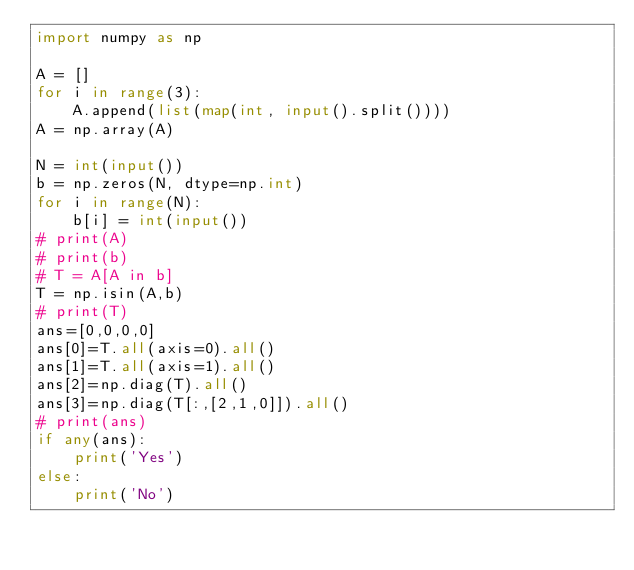<code> <loc_0><loc_0><loc_500><loc_500><_Python_>import numpy as np

A = []
for i in range(3):
    A.append(list(map(int, input().split())))
A = np.array(A)

N = int(input())
b = np.zeros(N, dtype=np.int)
for i in range(N):
    b[i] = int(input())
# print(A)
# print(b)
# T = A[A in b]
T = np.isin(A,b)
# print(T)
ans=[0,0,0,0]
ans[0]=T.all(axis=0).all()
ans[1]=T.all(axis=1).all()
ans[2]=np.diag(T).all()
ans[3]=np.diag(T[:,[2,1,0]]).all()
# print(ans)
if any(ans):
    print('Yes')
else:
    print('No')</code> 